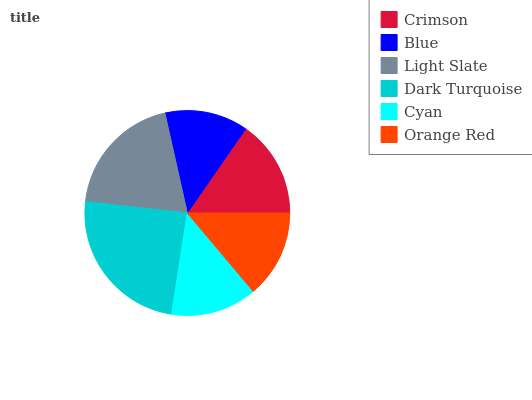Is Blue the minimum?
Answer yes or no. Yes. Is Dark Turquoise the maximum?
Answer yes or no. Yes. Is Light Slate the minimum?
Answer yes or no. No. Is Light Slate the maximum?
Answer yes or no. No. Is Light Slate greater than Blue?
Answer yes or no. Yes. Is Blue less than Light Slate?
Answer yes or no. Yes. Is Blue greater than Light Slate?
Answer yes or no. No. Is Light Slate less than Blue?
Answer yes or no. No. Is Crimson the high median?
Answer yes or no. Yes. Is Orange Red the low median?
Answer yes or no. Yes. Is Cyan the high median?
Answer yes or no. No. Is Dark Turquoise the low median?
Answer yes or no. No. 